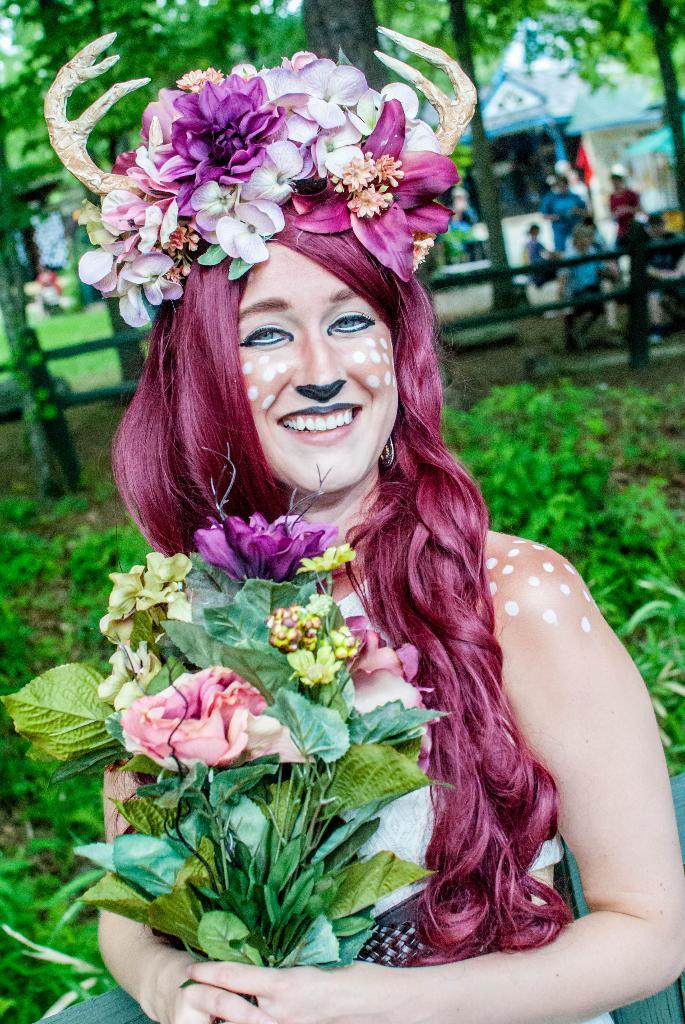What is the main subject of the image? There is a woman in the image. How is the woman dressed? The woman is dressed in a costume. What is the woman holding in the image? The woman is holding a bouquet. What can be seen in the background of the image? There is a wooden grill, plants, the ground, persons, buildings, and the sky visible in the background of the image. What type of drink is the woman holding in the image? There is no drink visible in the image; the woman is holding a bouquet. Can you describe the desk in the image? There is no desk present in the image. 